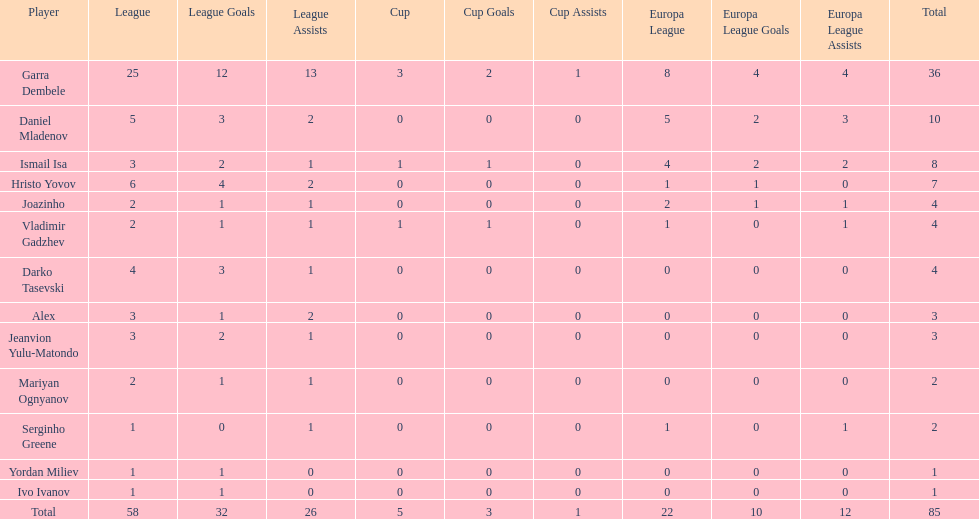How many goals did ismail isa score this season? 8. 